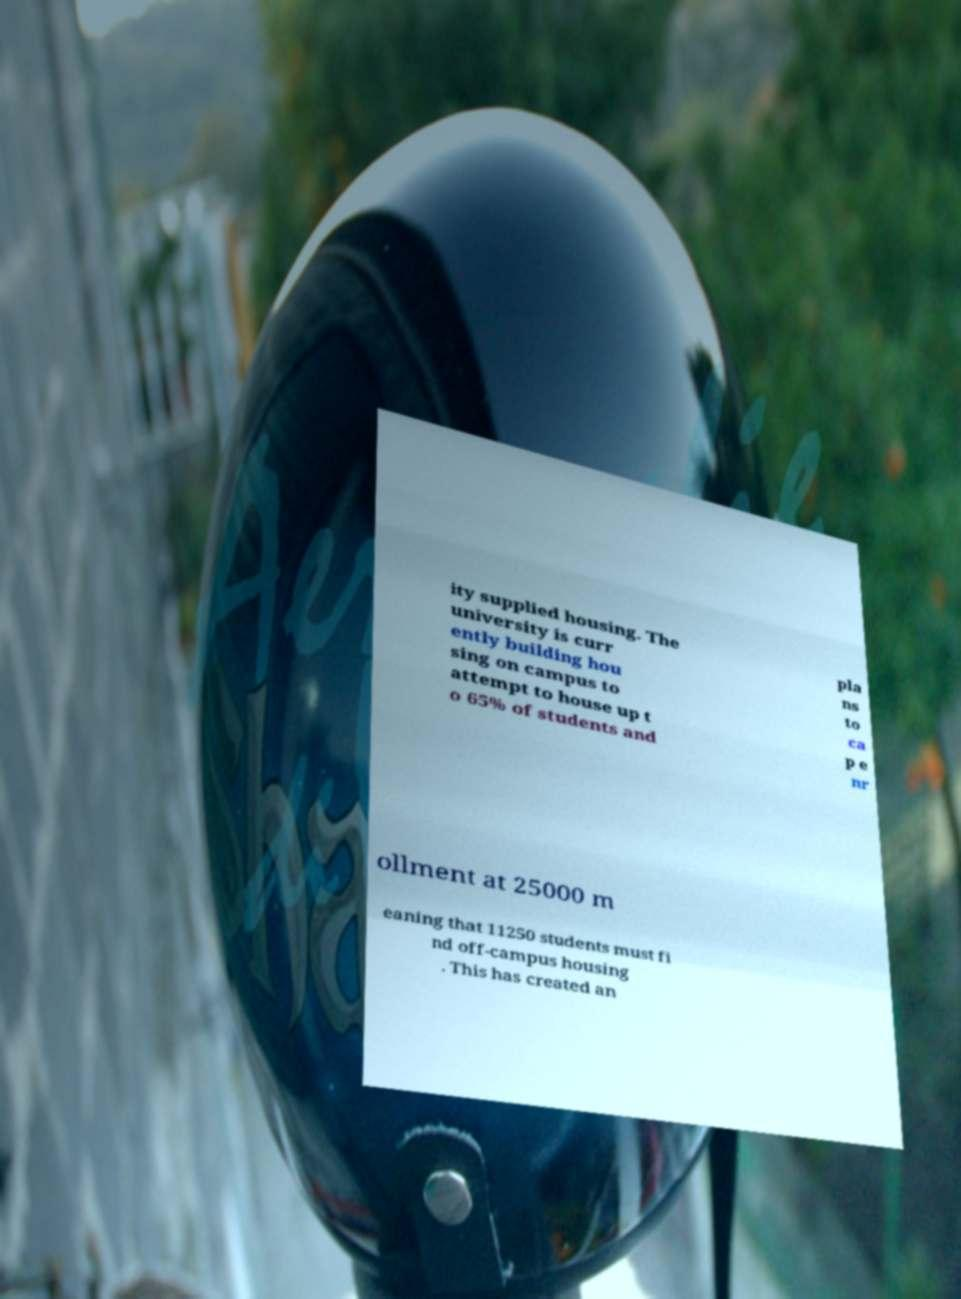Could you assist in decoding the text presented in this image and type it out clearly? ity supplied housing. The university is curr ently building hou sing on campus to attempt to house up t o 65% of students and pla ns to ca p e nr ollment at 25000 m eaning that 11250 students must fi nd off-campus housing . This has created an 